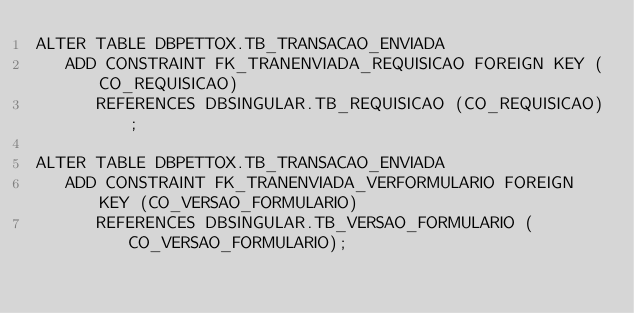<code> <loc_0><loc_0><loc_500><loc_500><_SQL_>ALTER TABLE DBPETTOX.TB_TRANSACAO_ENVIADA
   ADD CONSTRAINT FK_TRANENVIADA_REQUISICAO FOREIGN KEY (CO_REQUISICAO)
      REFERENCES DBSINGULAR.TB_REQUISICAO (CO_REQUISICAO);

ALTER TABLE DBPETTOX.TB_TRANSACAO_ENVIADA
   ADD CONSTRAINT FK_TRANENVIADA_VERFORMULARIO FOREIGN KEY (CO_VERSAO_FORMULARIO)
      REFERENCES DBSINGULAR.TB_VERSAO_FORMULARIO (CO_VERSAO_FORMULARIO);
</code> 